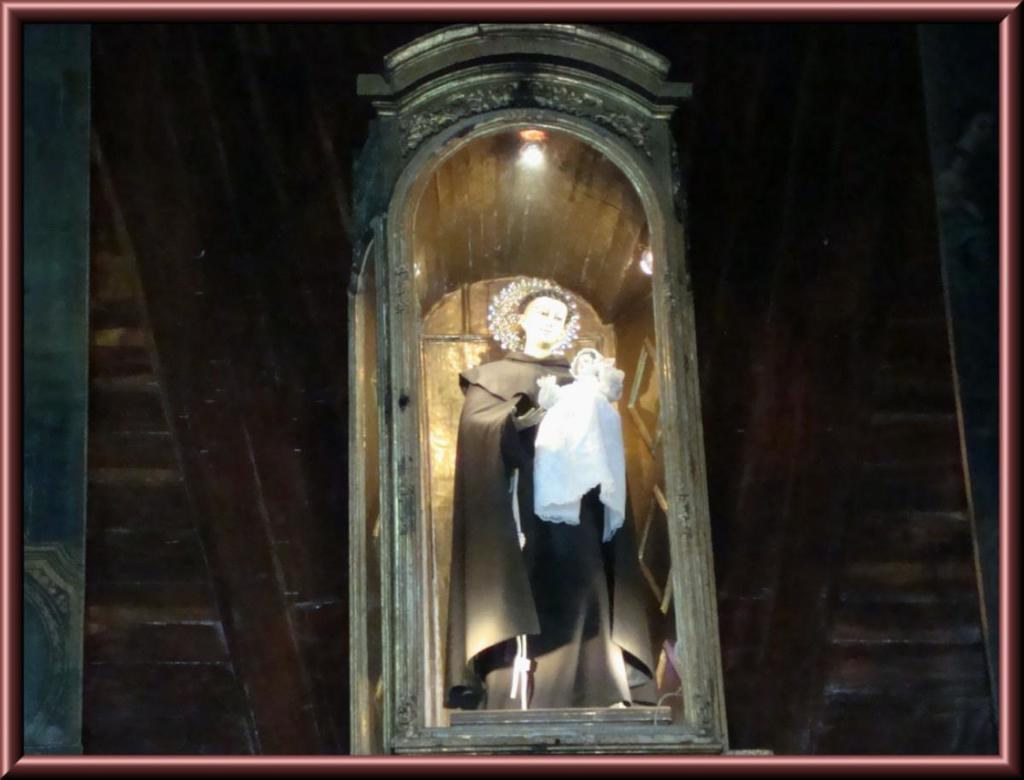What is: What is depicted in the sculpture in the image? There is a sculpture of two persons in the image. What can be seen attached to the roof and wall in the image? There are lights attached to the roof and wall in the image. What is the main architectural feature in the image? There is a wall in the image. What type of corn is growing on the canvas in the image? There is no corn or canvas present in the image. 